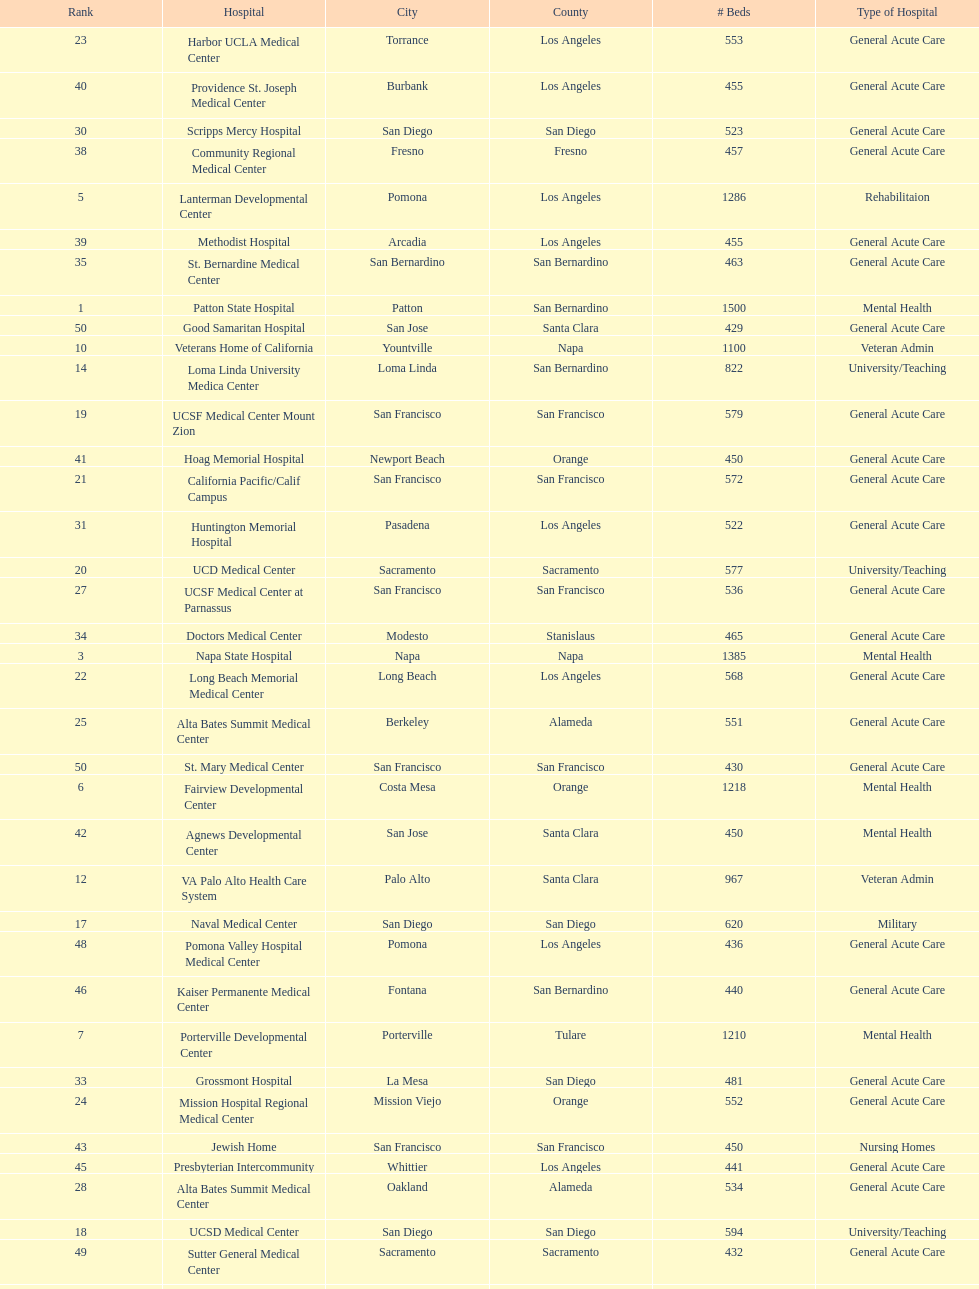Does patton state hospital in the city of patton in san bernardino county have more mental health hospital beds than atascadero state hospital in atascadero, san luis obispo county? Yes. 